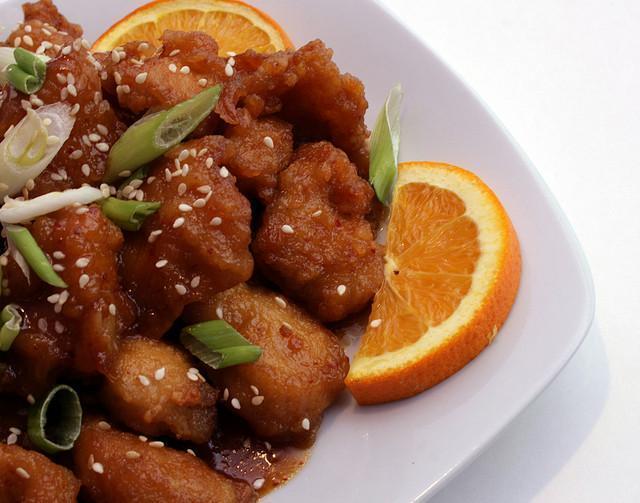How many oranges are in the photo?
Give a very brief answer. 2. 